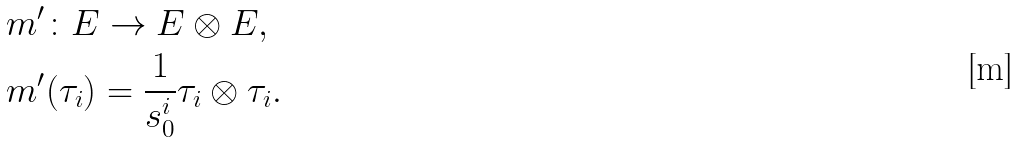Convert formula to latex. <formula><loc_0><loc_0><loc_500><loc_500>& m ^ { \prime } \colon E \rightarrow E \otimes E , \\ & m ^ { \prime } ( \tau _ { i } ) = \frac { 1 } { s _ { 0 } ^ { i } } \tau _ { i } \otimes \tau _ { i } .</formula> 